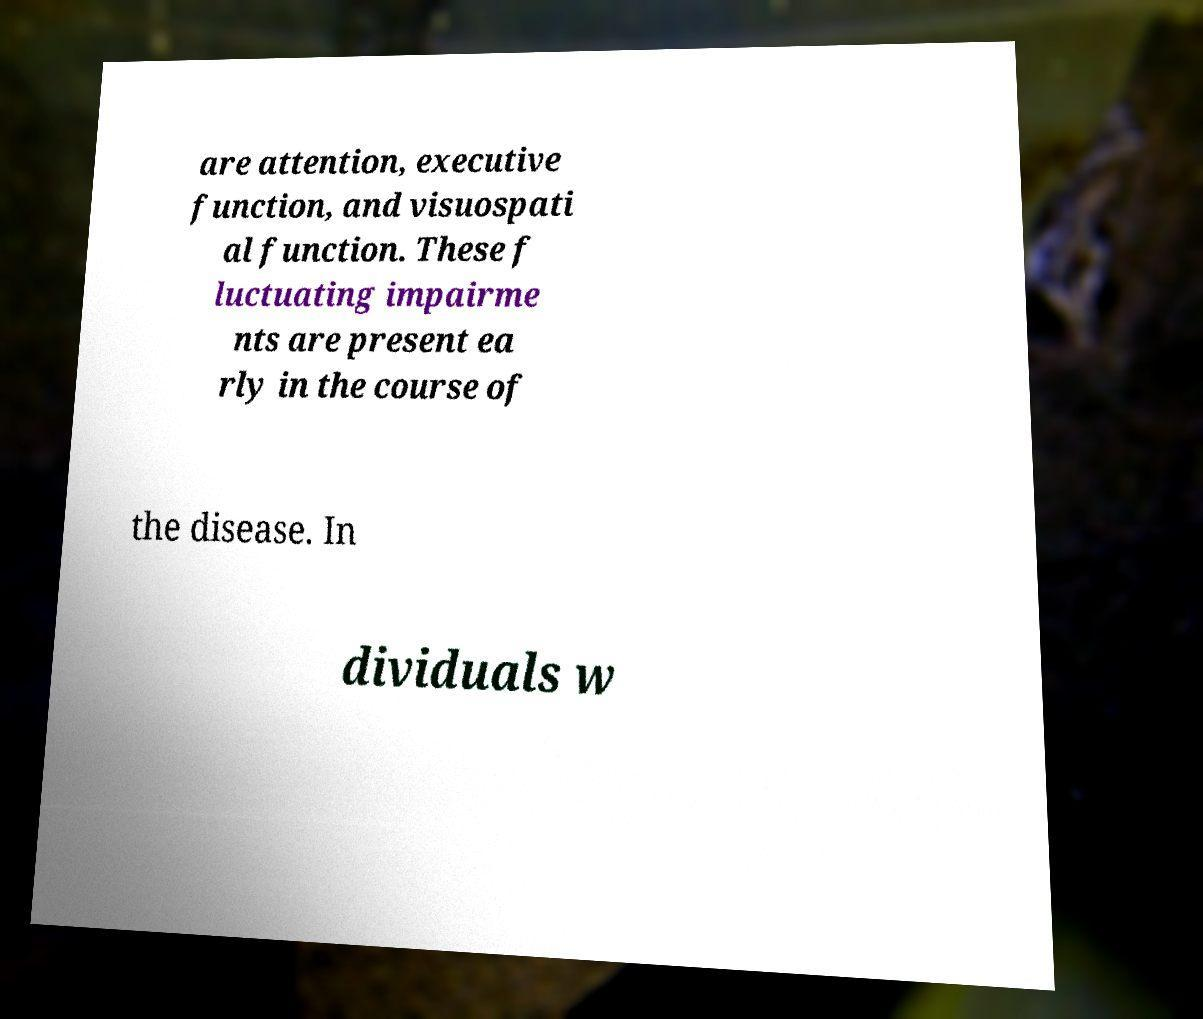There's text embedded in this image that I need extracted. Can you transcribe it verbatim? are attention, executive function, and visuospati al function. These f luctuating impairme nts are present ea rly in the course of the disease. In dividuals w 